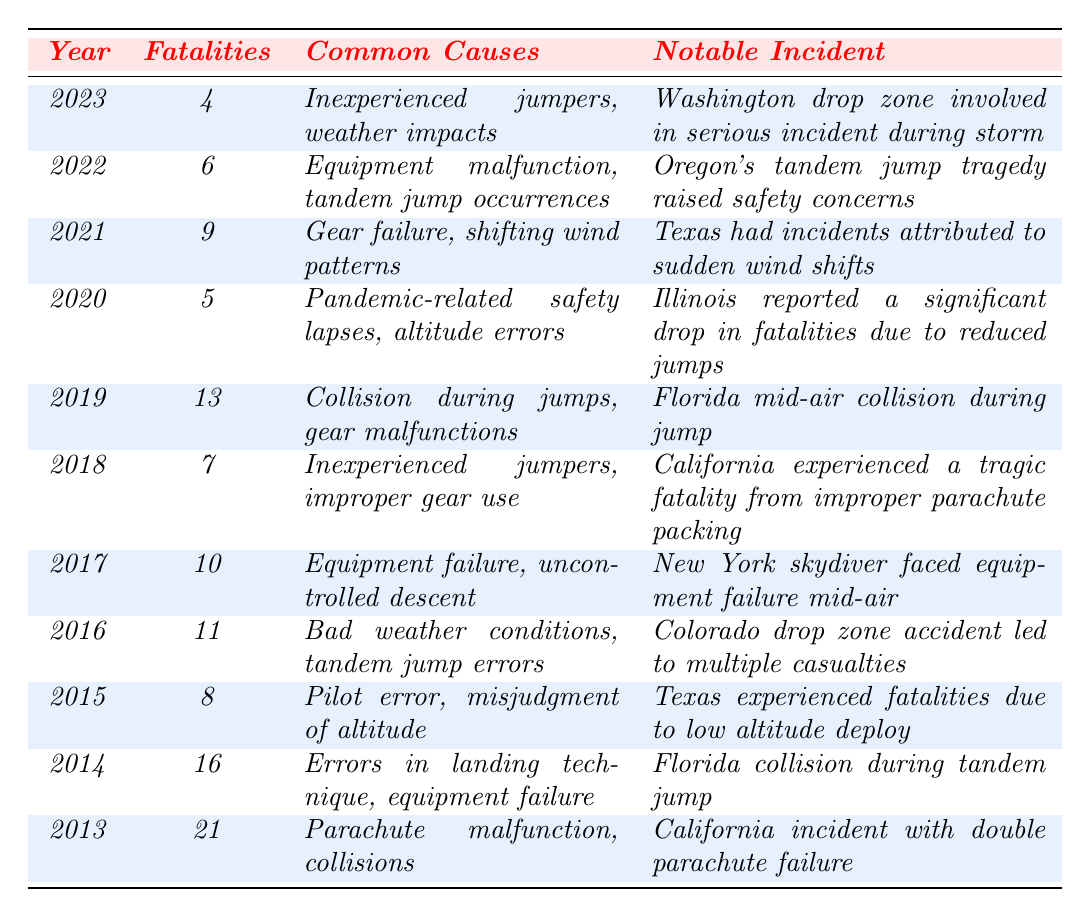What is the total number of skydiving fatalities recorded in the year 2020? From the table, the row for the year 2020 shows a total of 5 fatalities.
Answer: 5 Which year recorded the highest fatalities in skydiving? The table shows that 2013 had the highest fatalities with a total of 21.
Answer: 2013 What were the common causes of fatalities in 2019? The row for 2019 lists the common causes as collision during jumps and gear malfunctions.
Answer: Collision during jumps, gear malfunctions What was notable about the incident in 2014? In 2014, the notable incident involved a collision during a tandem jump in Florida.
Answer: Collision during tandem jump in Florida How many fatalities were recorded in the two most recent years combined? The two most recent years are 2022 (6 fatalities) and 2023 (4 fatalities). The sum is 6 + 4 = 10.
Answer: 10 What was the average number of fatalities over the entire period from 2013 to 2023? To find the average, first sum the total fatalities: 21 + 16 + 8 + 11 + 10 + 7 + 13 + 5 + 9 + 6 + 4 = 110. There are 11 years, so average = 110 / 11 = 10.
Answer: 10 Did the number of fatalities decrease from 2019 to 2020? Yes, the number of fatalities decreased from 13 in 2019 to 5 in 2020.
Answer: Yes What is the notable incident for the year 2018? The row for 2018 highlights a tragic fatality from improper parachute packing in California.
Answer: Improper parachute packing in California Which year had the least number of fatalities, and what were the common causes? The year with the least fatalities is 2023 with 4 fatalities, and the common causes are inexperienced jumpers and weather impacts.
Answer: 2023; inexperienced jumpers, weather impacts How many fatalities were caused by equipment failure over the decade? To find this, look at years 2014 (equipment failure), 2017 (equipment failure), 2022 (equipment malfunction), totaling 16 + 10 + 6 = 32 fatalities due to equipment-related causes.
Answer: 32 Which two years had a notable incident involving equipment failure? The years 2014 and 2017 both had notable incidents related to equipment failure.
Answer: 2014, 2017 